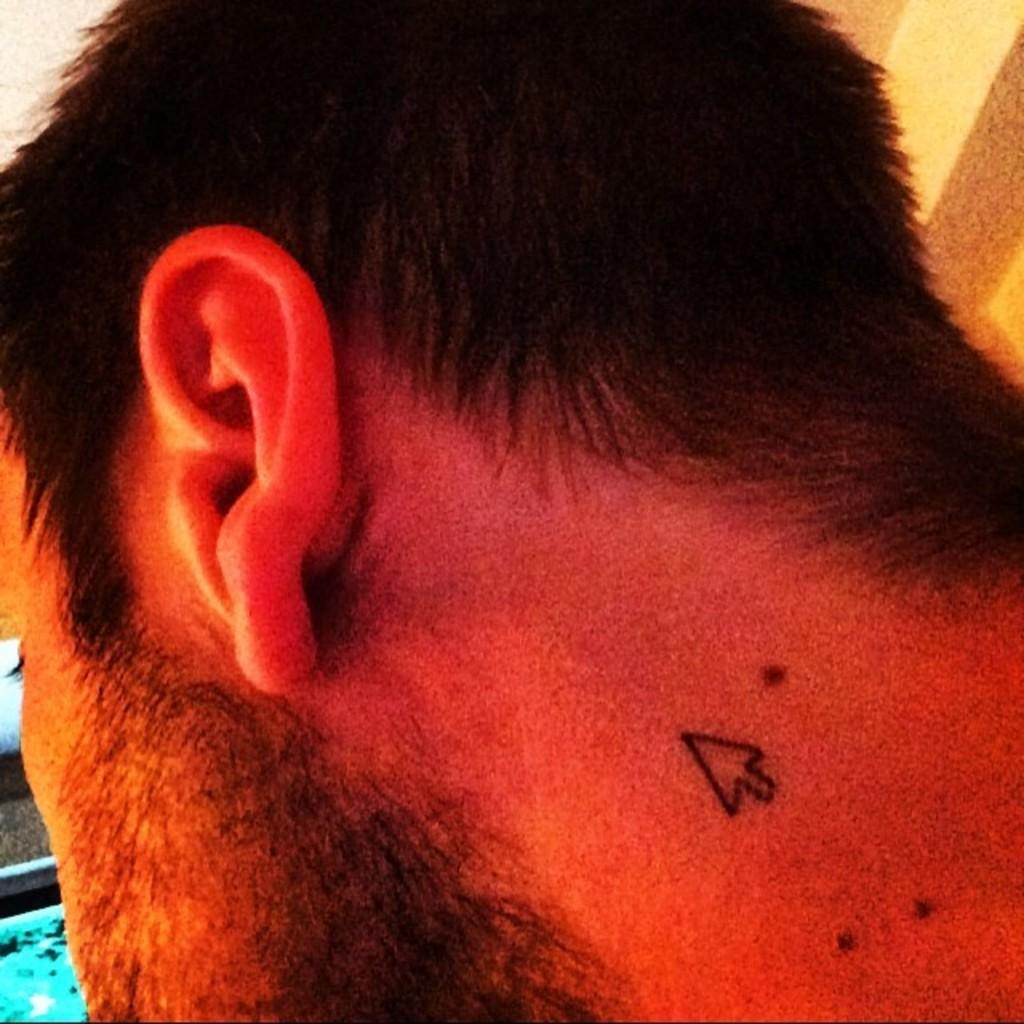What is present in the image? There is a person in the image. Can you describe the objects on the left side of the image? Unfortunately, the provided facts do not mention any specific objects on the left side of the image. How many women are playing baseball in the jail in the image? There are no women, baseball, or jail present in the image. 